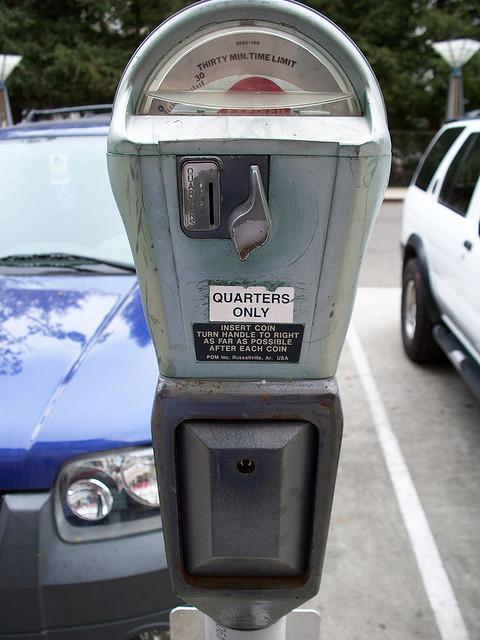How many slots are in the parking meter?
Give a very brief answer. 1. How many cars are there?
Give a very brief answer. 2. 